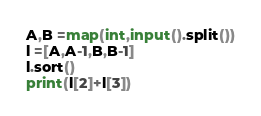Convert code to text. <code><loc_0><loc_0><loc_500><loc_500><_Python_>A,B =map(int,input().split())
l =[A,A-1,B,B-1]
l.sort()
print(l[2]+l[3])</code> 